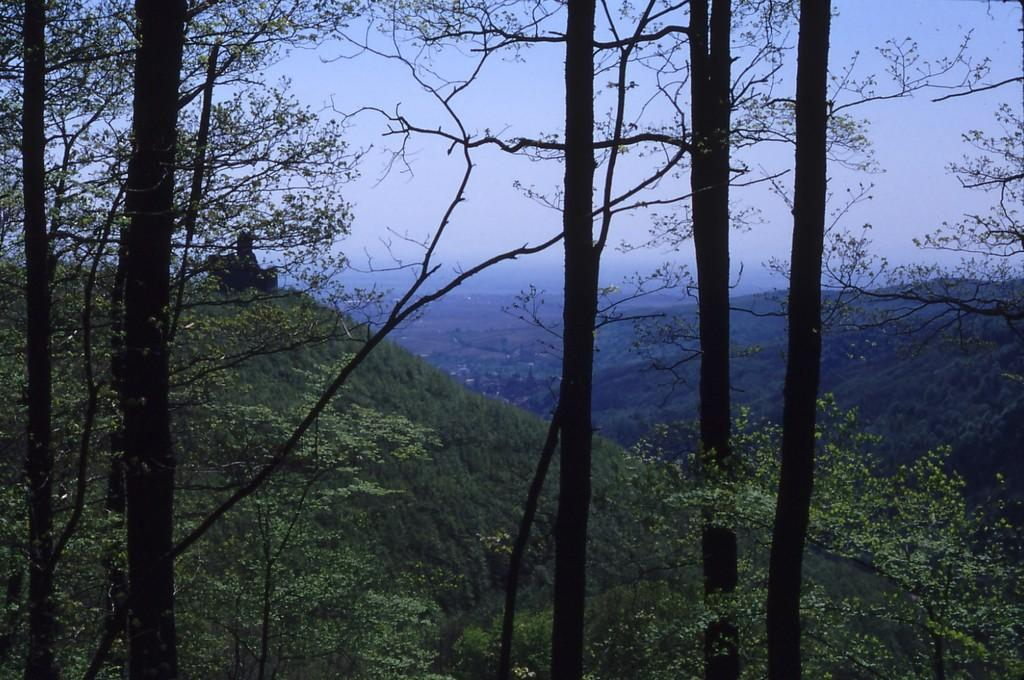What type of geographical feature is present in the image? There is a hill in the image. What type of vegetation can be seen in the image? There are trees in the image. What part of the natural environment is visible in the image? The sky is visible in the image. Are there any giants visible on the hill in the image? There are no giants present in the image. Is there any quicksand visible in the image? There is no quicksand present in the image. Can you see any lawyers in the image? There are no lawyers present in the image. 